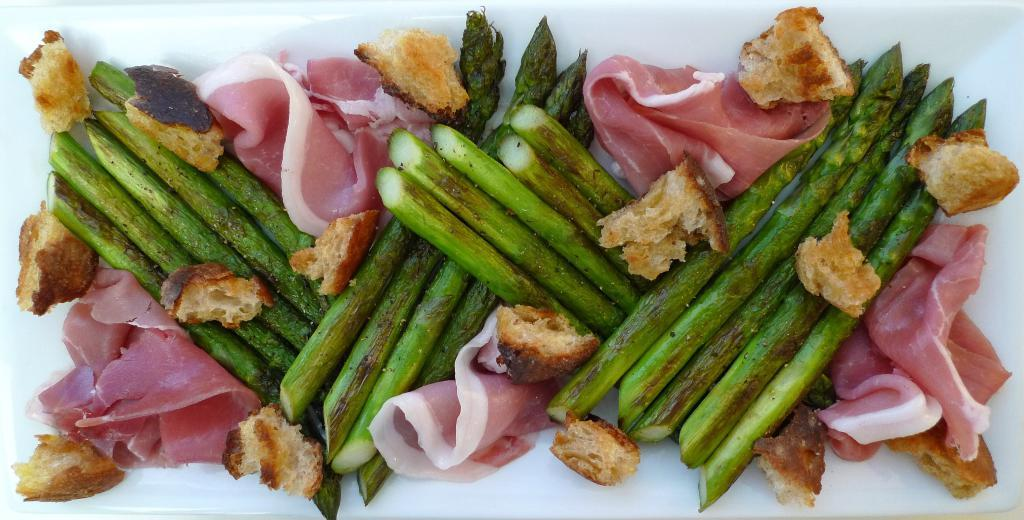What is located in the center of the image? There is a tray in the center of the image. What is on the tray? The tray contains food items. How does the pollution affect the food items on the tray? There is no indication of pollution in the image, so it cannot be determined how it might affect the food items on the tray. 